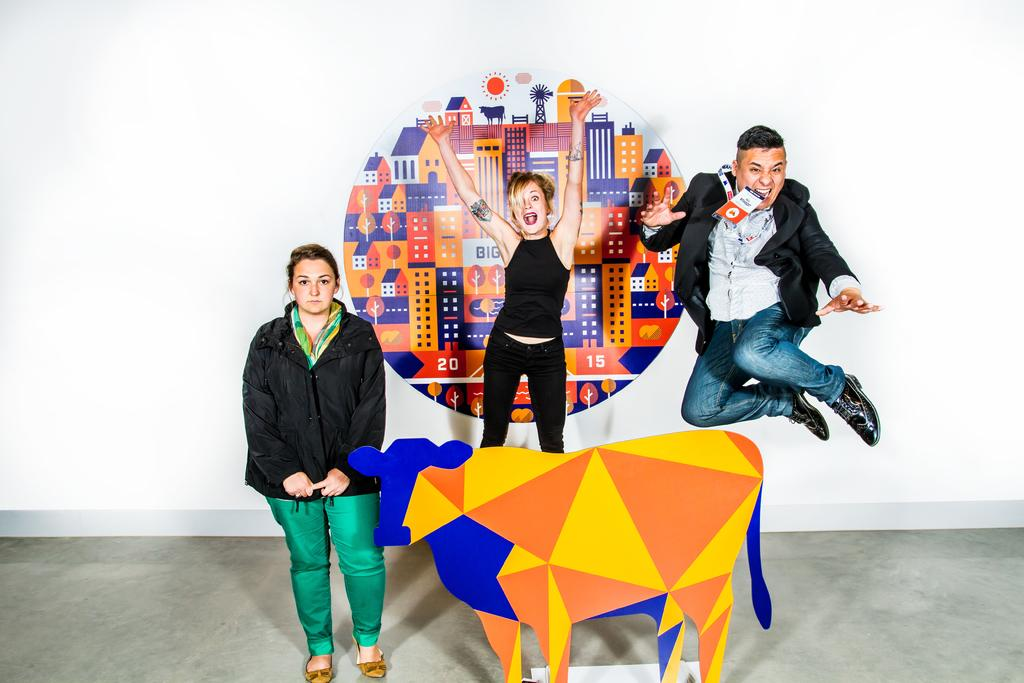How many people are in the image? There are two women and a man in the image. Where is the man positioned in relation to the women? The man is in the middle of the image. What is the object at the bottom of the image that resembles an animal? It is not clear what the object at the bottom of the image is, but it resembles an animal. What can be seen in the background of the image? There is a poster visible in the background of the image. Who is the owner of the vase in the image? There is no vase present in the image. Can you hear the conversation between the people in the image? The image is silent, so we cannot hear any conversation between the people. 